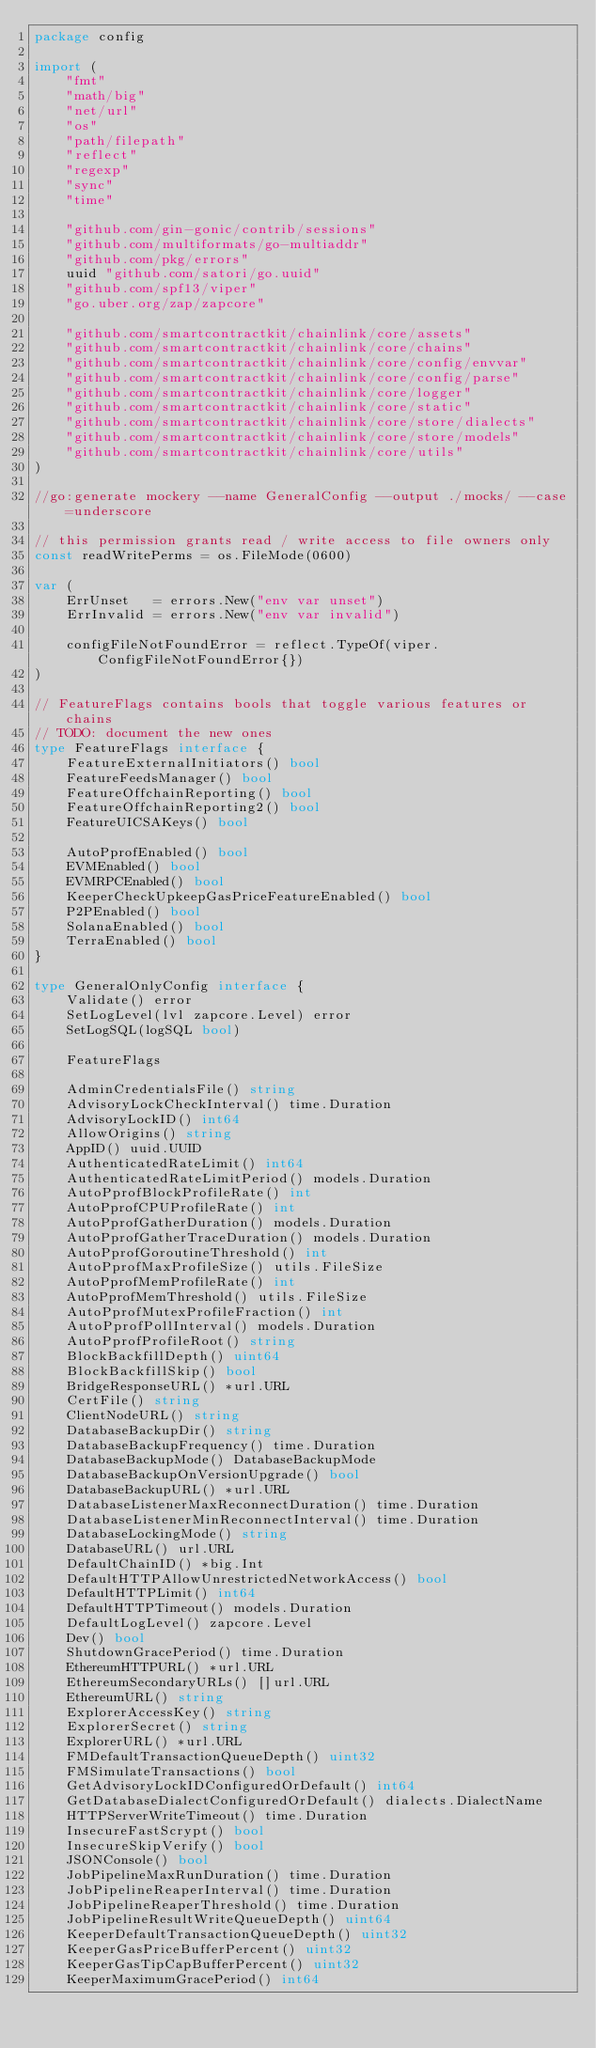Convert code to text. <code><loc_0><loc_0><loc_500><loc_500><_Go_>package config

import (
	"fmt"
	"math/big"
	"net/url"
	"os"
	"path/filepath"
	"reflect"
	"regexp"
	"sync"
	"time"

	"github.com/gin-gonic/contrib/sessions"
	"github.com/multiformats/go-multiaddr"
	"github.com/pkg/errors"
	uuid "github.com/satori/go.uuid"
	"github.com/spf13/viper"
	"go.uber.org/zap/zapcore"

	"github.com/smartcontractkit/chainlink/core/assets"
	"github.com/smartcontractkit/chainlink/core/chains"
	"github.com/smartcontractkit/chainlink/core/config/envvar"
	"github.com/smartcontractkit/chainlink/core/config/parse"
	"github.com/smartcontractkit/chainlink/core/logger"
	"github.com/smartcontractkit/chainlink/core/static"
	"github.com/smartcontractkit/chainlink/core/store/dialects"
	"github.com/smartcontractkit/chainlink/core/store/models"
	"github.com/smartcontractkit/chainlink/core/utils"
)

//go:generate mockery --name GeneralConfig --output ./mocks/ --case=underscore

// this permission grants read / write access to file owners only
const readWritePerms = os.FileMode(0600)

var (
	ErrUnset   = errors.New("env var unset")
	ErrInvalid = errors.New("env var invalid")

	configFileNotFoundError = reflect.TypeOf(viper.ConfigFileNotFoundError{})
)

// FeatureFlags contains bools that toggle various features or chains
// TODO: document the new ones
type FeatureFlags interface {
	FeatureExternalInitiators() bool
	FeatureFeedsManager() bool
	FeatureOffchainReporting() bool
	FeatureOffchainReporting2() bool
	FeatureUICSAKeys() bool

	AutoPprofEnabled() bool
	EVMEnabled() bool
	EVMRPCEnabled() bool
	KeeperCheckUpkeepGasPriceFeatureEnabled() bool
	P2PEnabled() bool
	SolanaEnabled() bool
	TerraEnabled() bool
}

type GeneralOnlyConfig interface {
	Validate() error
	SetLogLevel(lvl zapcore.Level) error
	SetLogSQL(logSQL bool)

	FeatureFlags

	AdminCredentialsFile() string
	AdvisoryLockCheckInterval() time.Duration
	AdvisoryLockID() int64
	AllowOrigins() string
	AppID() uuid.UUID
	AuthenticatedRateLimit() int64
	AuthenticatedRateLimitPeriod() models.Duration
	AutoPprofBlockProfileRate() int
	AutoPprofCPUProfileRate() int
	AutoPprofGatherDuration() models.Duration
	AutoPprofGatherTraceDuration() models.Duration
	AutoPprofGoroutineThreshold() int
	AutoPprofMaxProfileSize() utils.FileSize
	AutoPprofMemProfileRate() int
	AutoPprofMemThreshold() utils.FileSize
	AutoPprofMutexProfileFraction() int
	AutoPprofPollInterval() models.Duration
	AutoPprofProfileRoot() string
	BlockBackfillDepth() uint64
	BlockBackfillSkip() bool
	BridgeResponseURL() *url.URL
	CertFile() string
	ClientNodeURL() string
	DatabaseBackupDir() string
	DatabaseBackupFrequency() time.Duration
	DatabaseBackupMode() DatabaseBackupMode
	DatabaseBackupOnVersionUpgrade() bool
	DatabaseBackupURL() *url.URL
	DatabaseListenerMaxReconnectDuration() time.Duration
	DatabaseListenerMinReconnectInterval() time.Duration
	DatabaseLockingMode() string
	DatabaseURL() url.URL
	DefaultChainID() *big.Int
	DefaultHTTPAllowUnrestrictedNetworkAccess() bool
	DefaultHTTPLimit() int64
	DefaultHTTPTimeout() models.Duration
	DefaultLogLevel() zapcore.Level
	Dev() bool
	ShutdownGracePeriod() time.Duration
	EthereumHTTPURL() *url.URL
	EthereumSecondaryURLs() []url.URL
	EthereumURL() string
	ExplorerAccessKey() string
	ExplorerSecret() string
	ExplorerURL() *url.URL
	FMDefaultTransactionQueueDepth() uint32
	FMSimulateTransactions() bool
	GetAdvisoryLockIDConfiguredOrDefault() int64
	GetDatabaseDialectConfiguredOrDefault() dialects.DialectName
	HTTPServerWriteTimeout() time.Duration
	InsecureFastScrypt() bool
	InsecureSkipVerify() bool
	JSONConsole() bool
	JobPipelineMaxRunDuration() time.Duration
	JobPipelineReaperInterval() time.Duration
	JobPipelineReaperThreshold() time.Duration
	JobPipelineResultWriteQueueDepth() uint64
	KeeperDefaultTransactionQueueDepth() uint32
	KeeperGasPriceBufferPercent() uint32
	KeeperGasTipCapBufferPercent() uint32
	KeeperMaximumGracePeriod() int64</code> 